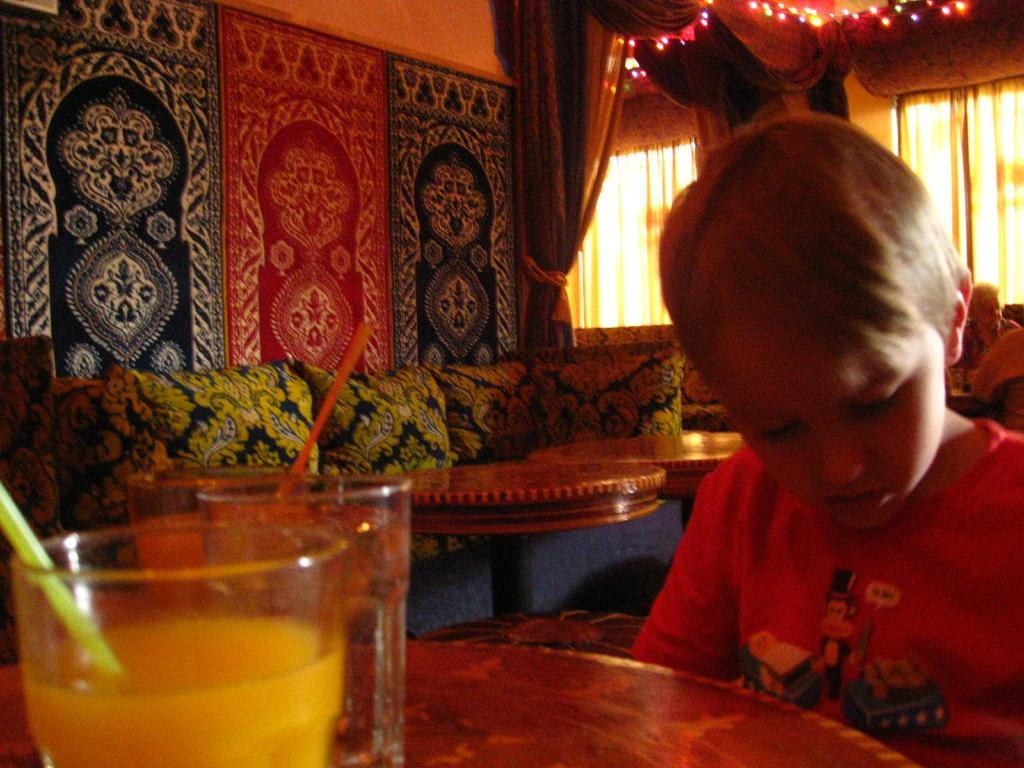Could you give a brief overview of what you see in this image? In the image we can see one boy sitting around the table on table there is a glass. In the background there is a we can see sheer,curtain,window,wall,couch,table and pillows. 